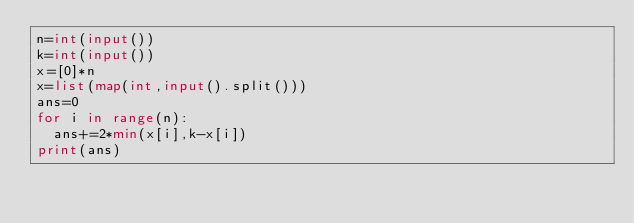<code> <loc_0><loc_0><loc_500><loc_500><_Python_>n=int(input())
k=int(input())
x=[0]*n
x=list(map(int,input().split()))
ans=0
for i in range(n):
  ans+=2*min(x[i],k-x[i])
print(ans)</code> 